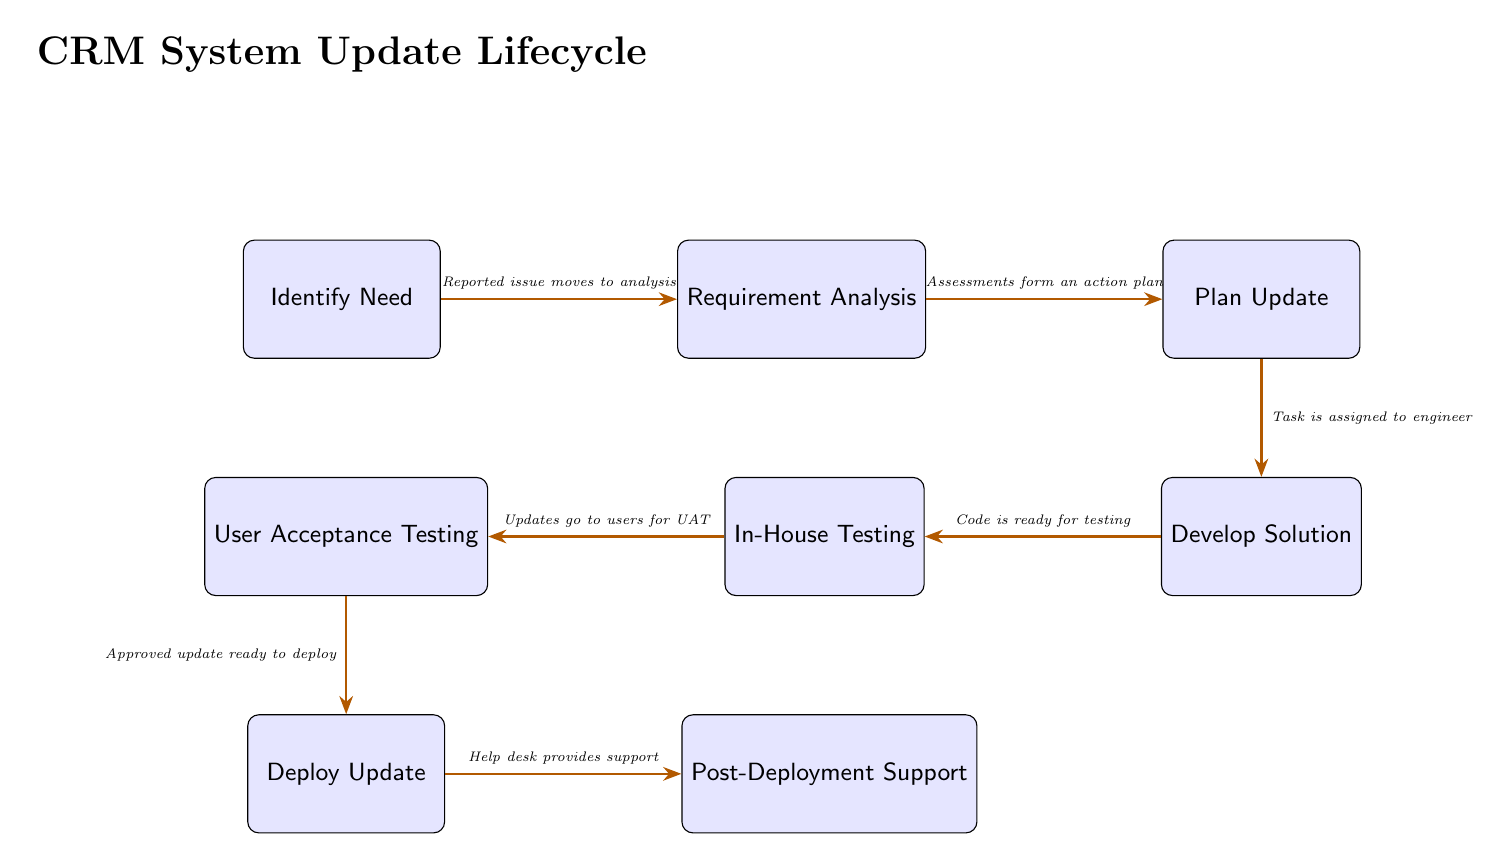What is the first step in the CRM system update lifecycle? The first step shown in the diagram is "Identify Need," as it is represented as the initial node leading the process.
Answer: Identify Need How many nodes are in the diagram? By counting the boxes representing specific steps, we see a total of seven nodes in the process: Identify Need, Requirement Analysis, Plan Update, Develop Solution, In-House Testing, User Acceptance Testing, Deploy Update, and Post-Deployment Support.
Answer: Seven What is the action that follows "Plan Update"? The diagram indicates that the action following "Plan Update" is "Develop Solution," indicating the progression from planning to the actual development phase.
Answer: Develop Solution Which node precedes "User Acceptance Testing"? The diagram shows that "In-House Testing" is the step immediately before "User Acceptance Testing," indicating this order in testing.
Answer: In-House Testing What step comes after "Deploy Update"? The next step indicated in the diagram, following "Deploy Update," is "Post-Deployment Support," highlighting the support phase after deployment.
Answer: Post-Deployment Support How does "Requirement Analysis" relate to "Identify Need"? The diagram illustrates that "Requirement Analysis" comes directly after "Identify Need," signifying that once a need is identified, it moves into the analysis phase for requirements.
Answer: Requirement Analysis What is the significance of "User Acceptance Testing"? It is a crucial phase in the diagram as it ensures that users have validated the solution before moving to deployment, essentially serving as the last checkpoint before release.
Answer: User Acceptance Testing What node is responsible for providing support after the update? "Post-Deployment Support" is indicated as the node responsible for support after the update is deployed, showing continuity of service and assistance to users.
Answer: Post-Deployment Support What does the arrow between "Develop Solution" and "In-House Testing" represent? The arrow signifies the flow of the process, indicating that once the solution is developed, it transitions to in-house testing for verification and quality assurance.
Answer: In-House Testing 